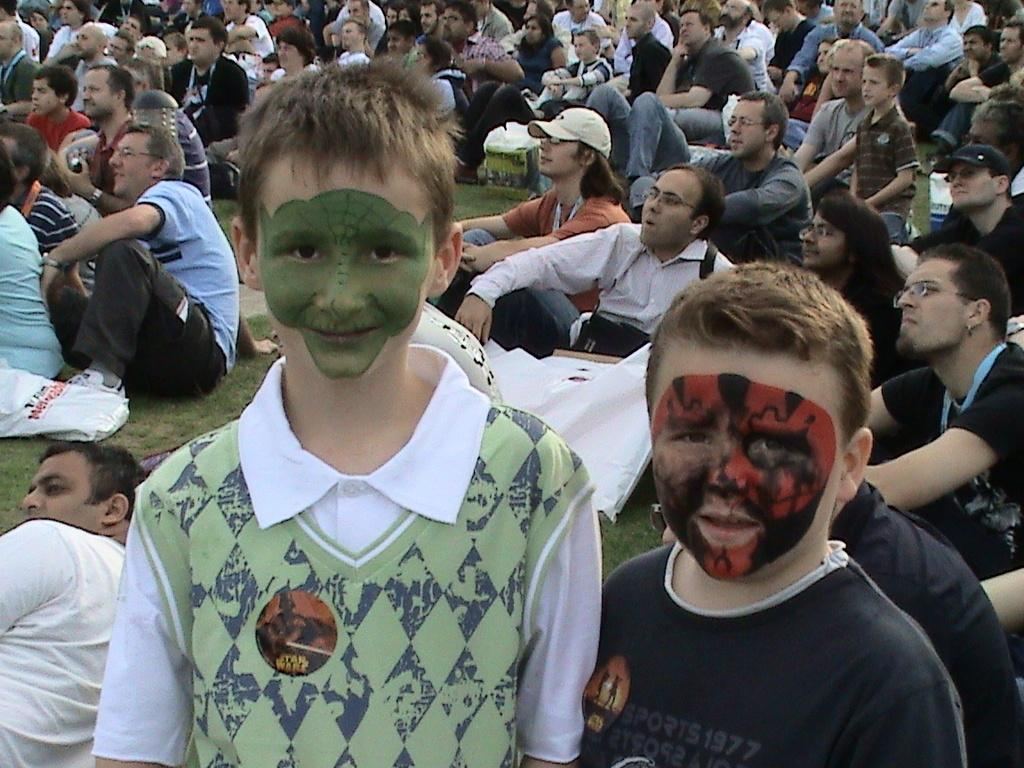What are the people in the image doing? The people in the image are sitting on the grass. Can you describe any additional features of the people in the image? Some of the people have face paint. What is the caption for the image? There is no caption provided with the image, so it cannot be determined. 